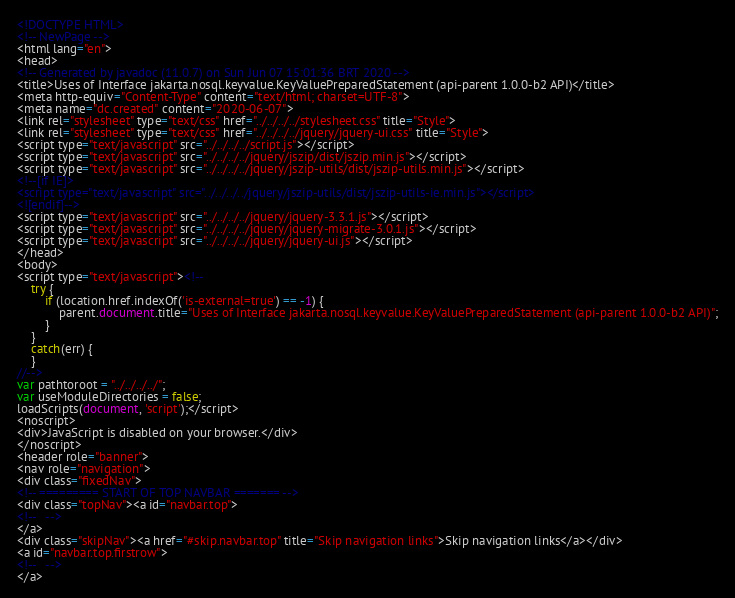<code> <loc_0><loc_0><loc_500><loc_500><_HTML_><!DOCTYPE HTML>
<!-- NewPage -->
<html lang="en">
<head>
<!-- Generated by javadoc (11.0.7) on Sun Jun 07 15:01:36 BRT 2020 -->
<title>Uses of Interface jakarta.nosql.keyvalue.KeyValuePreparedStatement (api-parent 1.0.0-b2 API)</title>
<meta http-equiv="Content-Type" content="text/html; charset=UTF-8">
<meta name="dc.created" content="2020-06-07">
<link rel="stylesheet" type="text/css" href="../../../../stylesheet.css" title="Style">
<link rel="stylesheet" type="text/css" href="../../../../jquery/jquery-ui.css" title="Style">
<script type="text/javascript" src="../../../../script.js"></script>
<script type="text/javascript" src="../../../../jquery/jszip/dist/jszip.min.js"></script>
<script type="text/javascript" src="../../../../jquery/jszip-utils/dist/jszip-utils.min.js"></script>
<!--[if IE]>
<script type="text/javascript" src="../../../../jquery/jszip-utils/dist/jszip-utils-ie.min.js"></script>
<![endif]-->
<script type="text/javascript" src="../../../../jquery/jquery-3.3.1.js"></script>
<script type="text/javascript" src="../../../../jquery/jquery-migrate-3.0.1.js"></script>
<script type="text/javascript" src="../../../../jquery/jquery-ui.js"></script>
</head>
<body>
<script type="text/javascript"><!--
    try {
        if (location.href.indexOf('is-external=true') == -1) {
            parent.document.title="Uses of Interface jakarta.nosql.keyvalue.KeyValuePreparedStatement (api-parent 1.0.0-b2 API)";
        }
    }
    catch(err) {
    }
//-->
var pathtoroot = "../../../../";
var useModuleDirectories = false;
loadScripts(document, 'script');</script>
<noscript>
<div>JavaScript is disabled on your browser.</div>
</noscript>
<header role="banner">
<nav role="navigation">
<div class="fixedNav">
<!-- ========= START OF TOP NAVBAR ======= -->
<div class="topNav"><a id="navbar.top">
<!--   -->
</a>
<div class="skipNav"><a href="#skip.navbar.top" title="Skip navigation links">Skip navigation links</a></div>
<a id="navbar.top.firstrow">
<!--   -->
</a></code> 